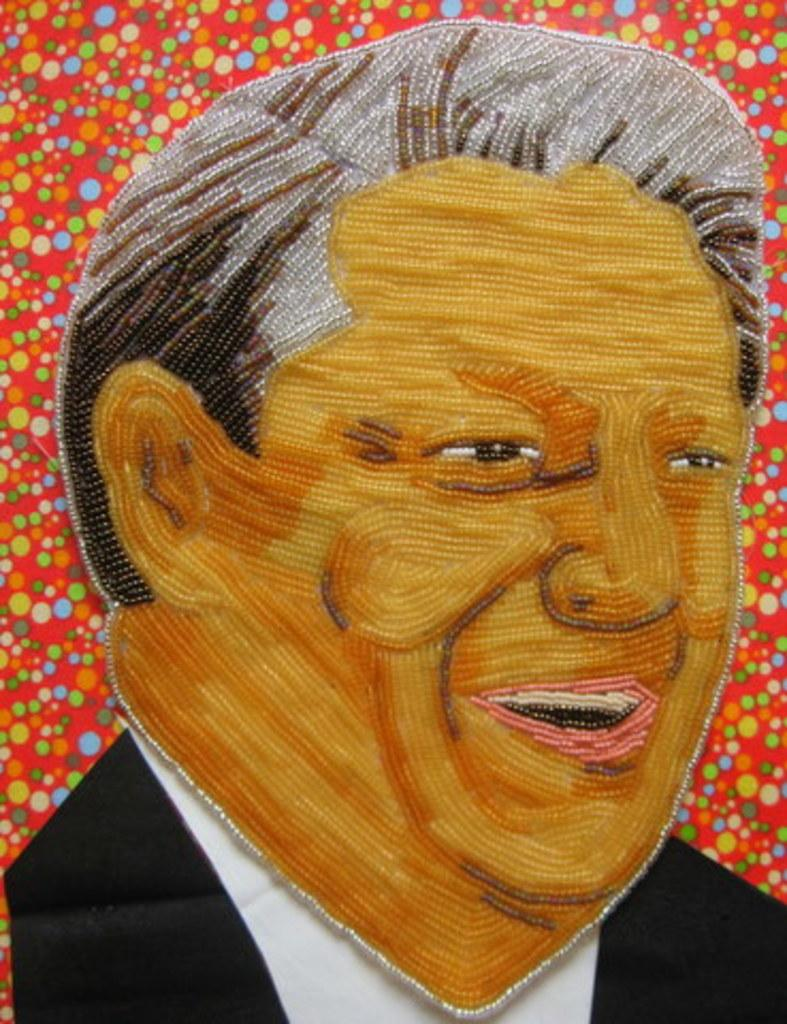What is the main subject of the image? There is a painting in the image. What is the painting depicting? The painting depicts a man. What is the man wearing in the painting? The man is wearing a black color jacket. What type of pancake is being served on the side of the painting? There is no pancake present in the image; it is a painting of a man wearing a black jacket. 